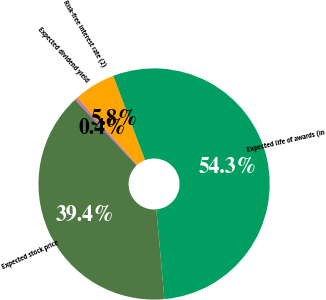Convert chart to OTSL. <chart><loc_0><loc_0><loc_500><loc_500><pie_chart><fcel>Risk-free interest rate (2)<fcel>Expected dividend yield<fcel>Expected stock price<fcel>Expected life of awards (in<nl><fcel>5.82%<fcel>0.43%<fcel>39.43%<fcel>54.31%<nl></chart> 